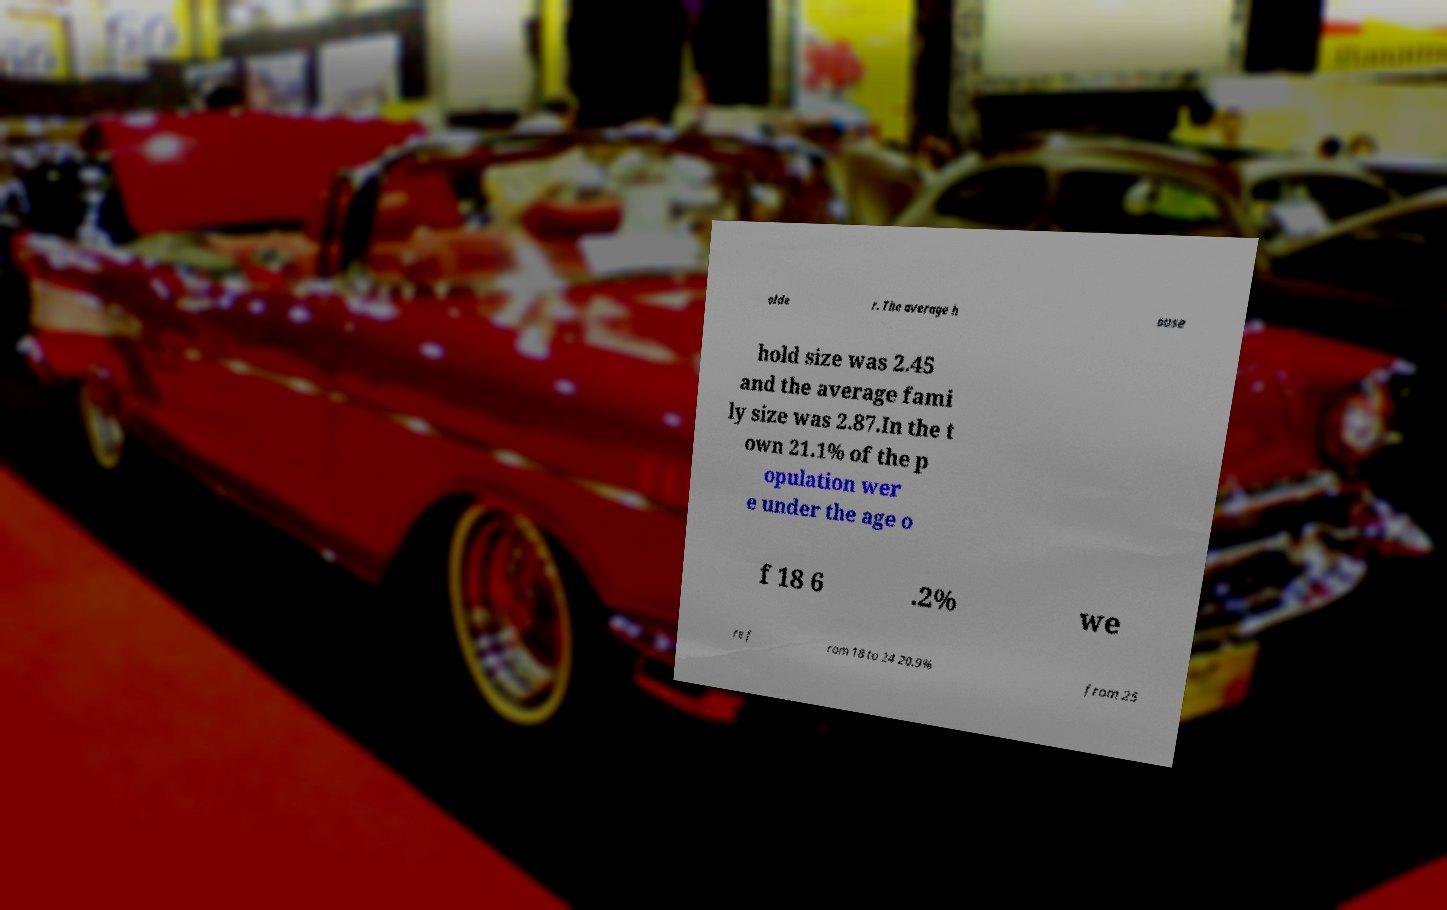Can you read and provide the text displayed in the image?This photo seems to have some interesting text. Can you extract and type it out for me? olde r. The average h ouse hold size was 2.45 and the average fami ly size was 2.87.In the t own 21.1% of the p opulation wer e under the age o f 18 6 .2% we re f rom 18 to 24 20.9% from 25 